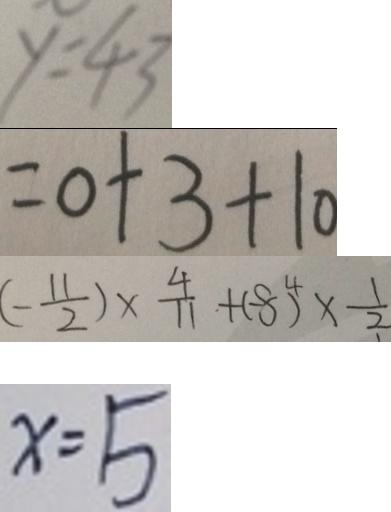<formula> <loc_0><loc_0><loc_500><loc_500>y = 4 3 
 = 0 + 3 + 1 0 
 ( - \frac { 1 1 } { 2 } ) \times \frac { 4 } { 1 1 } + ( - 8 ) ^ { 4 } \times \frac { 1 } { 2 } 
 x = 5</formula> 